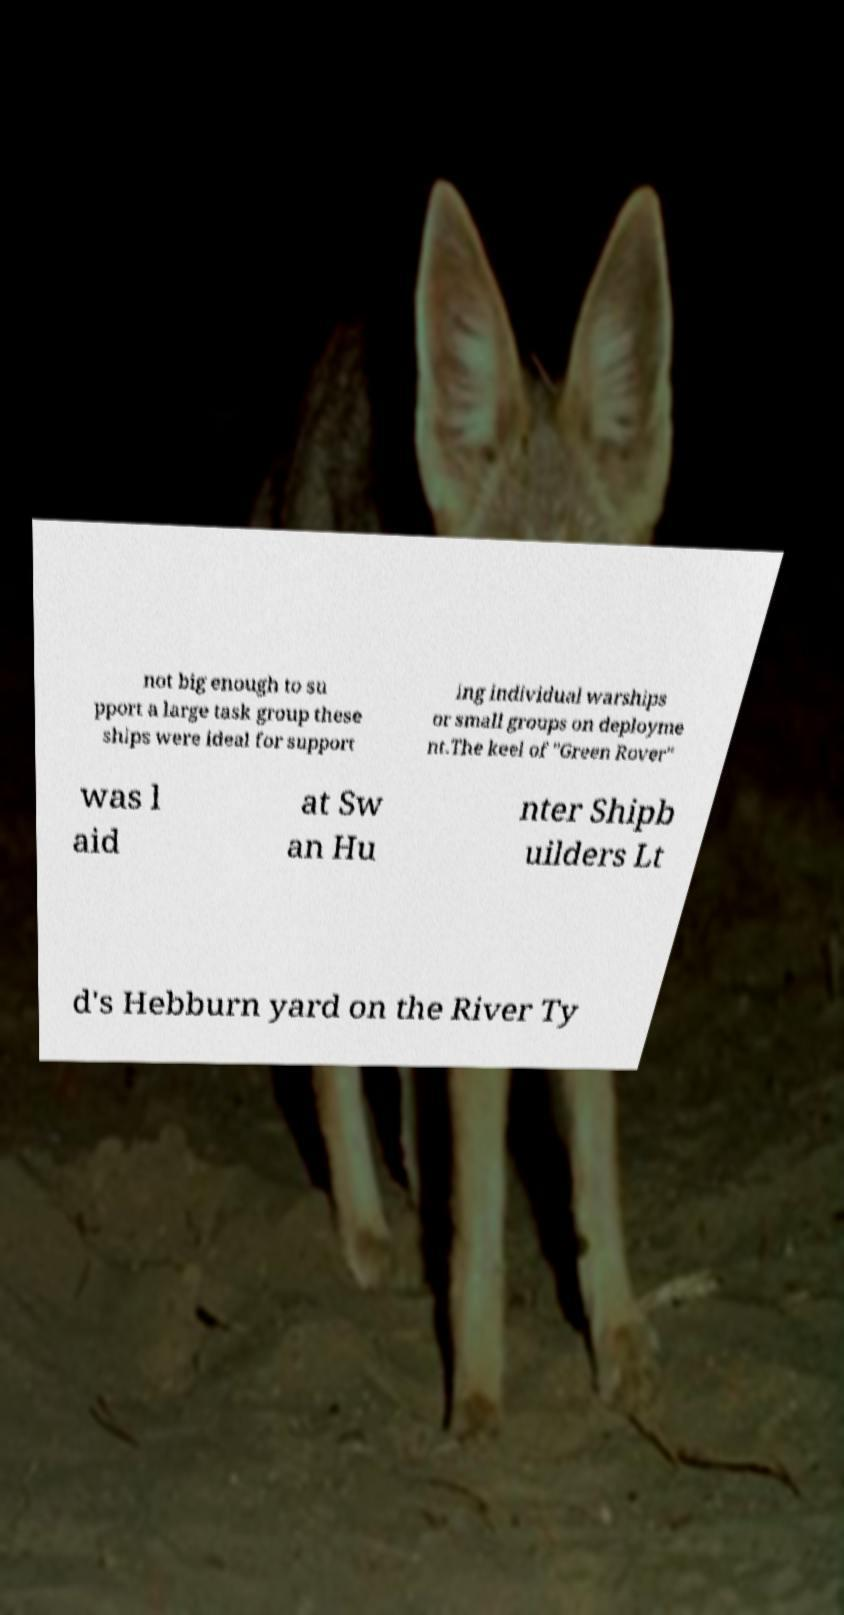Could you assist in decoding the text presented in this image and type it out clearly? not big enough to su pport a large task group these ships were ideal for support ing individual warships or small groups on deployme nt.The keel of "Green Rover" was l aid at Sw an Hu nter Shipb uilders Lt d's Hebburn yard on the River Ty 